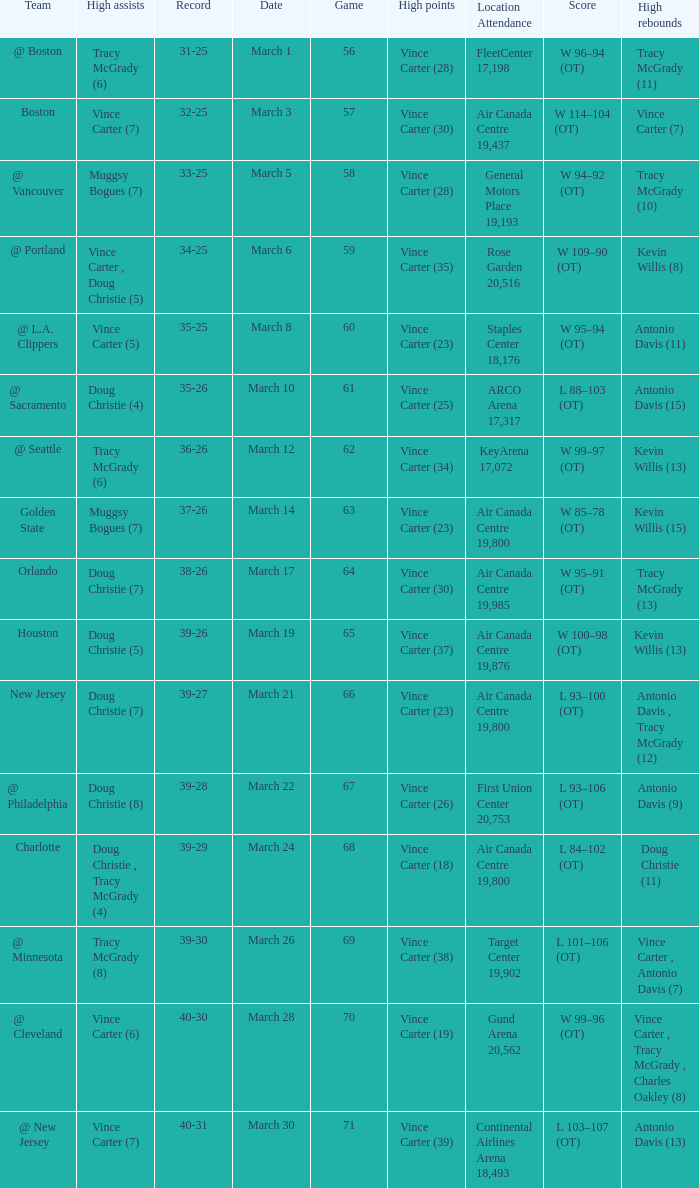How many people had the high assists @ minnesota? 1.0. 